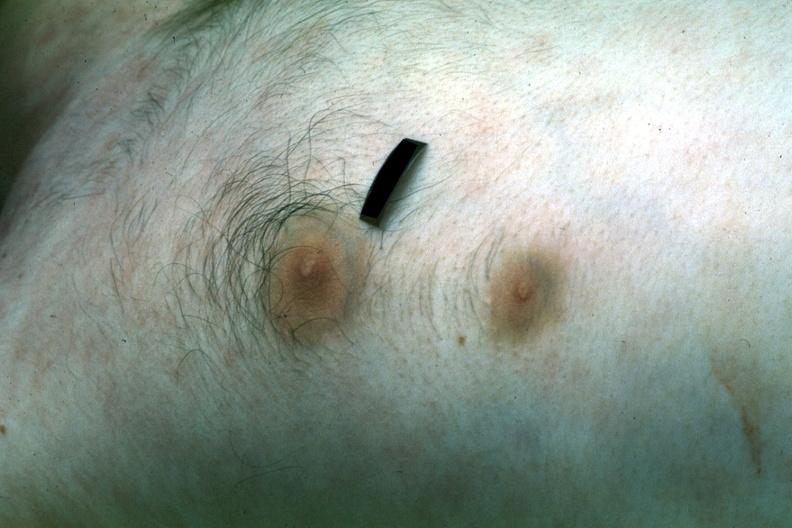what is present?
Answer the question using a single word or phrase. Breast 